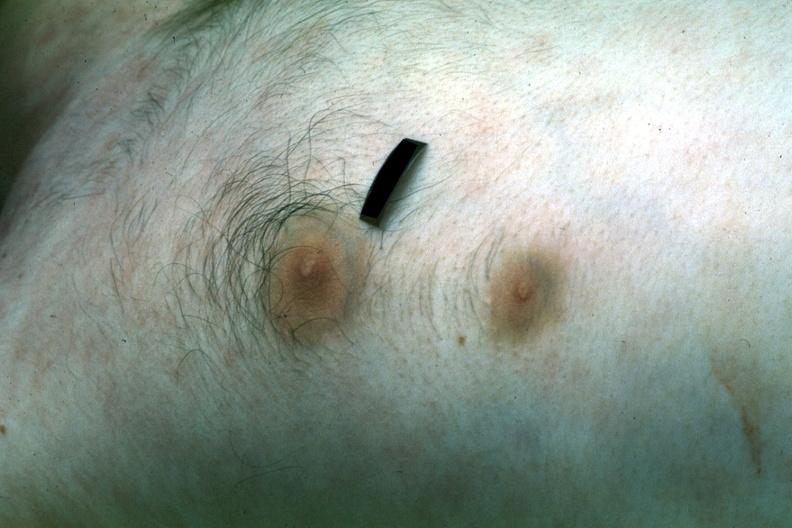what is present?
Answer the question using a single word or phrase. Breast 